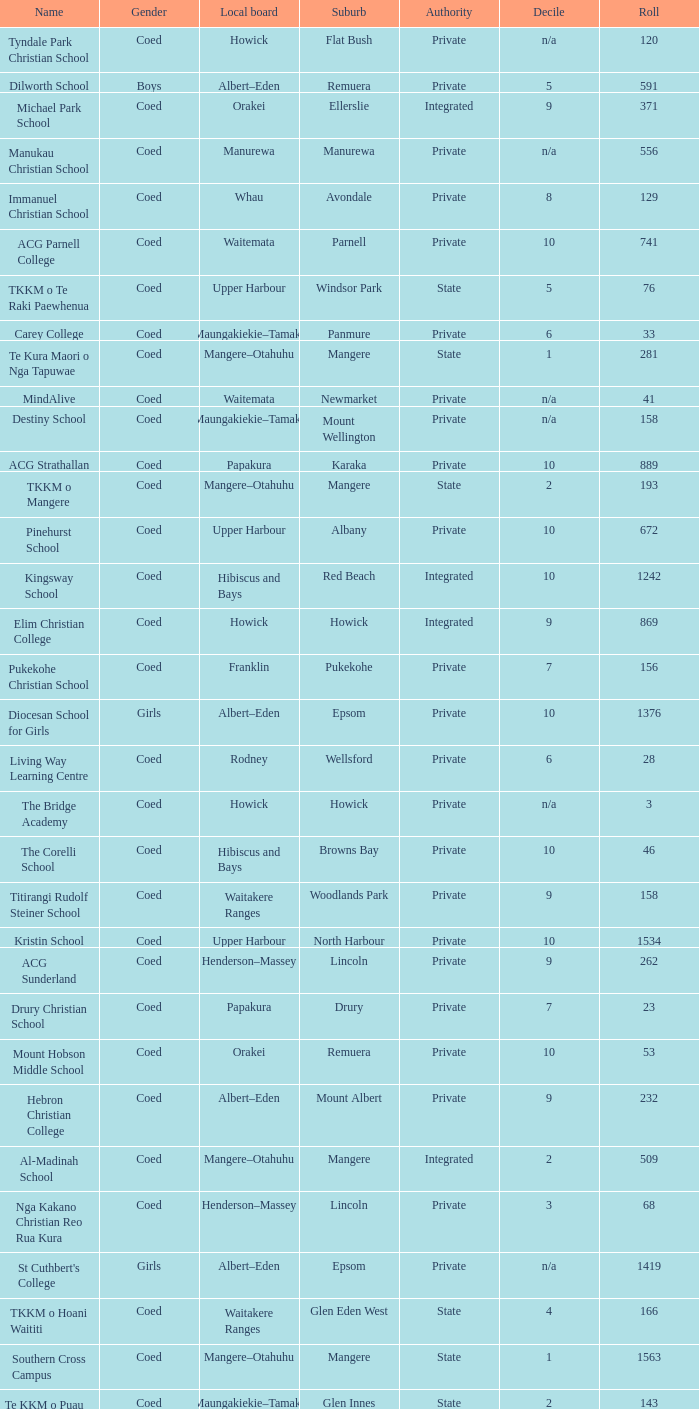What is the name of the suburb with a roll of 741? Parnell. 